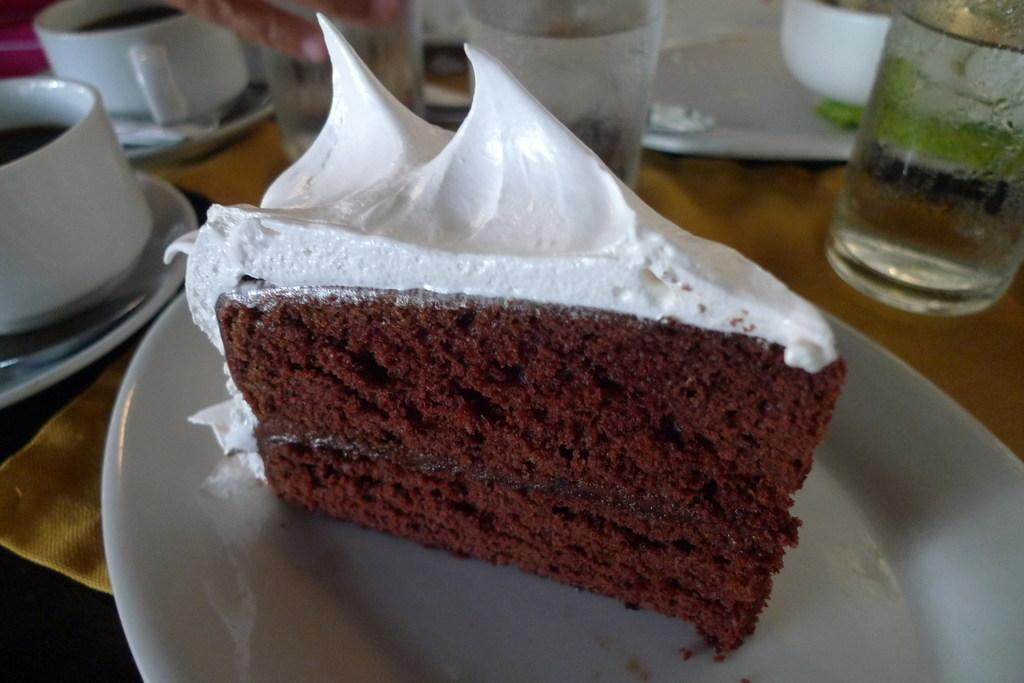What is the main subject of the image? There is a cake in the image. How is the cake presented? The cake is on a plate. What other items can be seen in the background of the image? There are cups, saucers, and glasses in the background of the image. Are there any other objects visible in the background? Yes, there are other objects visible in the background. What type of chain is being pointed at by the father in the image? There is no father or chain present in the image. What is the father pointing at in the image? There is no father present in the image, so it is not possible to determine what he might be pointing at. 